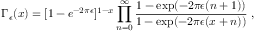<formula> <loc_0><loc_0><loc_500><loc_500>\Gamma _ { \epsilon } ( x ) = [ 1 - e ^ { - 2 \pi \epsilon } ] ^ { 1 - x } \prod _ { n = 0 } ^ { \infty } { \frac { 1 - \exp ( - 2 \pi \epsilon ( n + 1 ) ) } { 1 - \exp ( - 2 \pi \epsilon ( x + n ) ) } } \ ,</formula> 